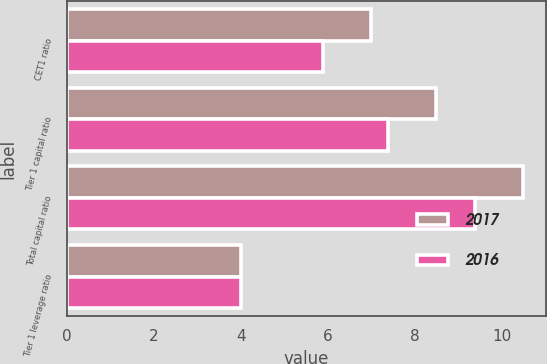Convert chart. <chart><loc_0><loc_0><loc_500><loc_500><stacked_bar_chart><ecel><fcel>CET1 ratio<fcel>Tier 1 capital ratio<fcel>Total capital ratio<fcel>Tier 1 leverage ratio<nl><fcel>2017<fcel>7<fcel>8.5<fcel>10.5<fcel>4<nl><fcel>2016<fcel>5.88<fcel>7.38<fcel>9.38<fcel>4<nl></chart> 